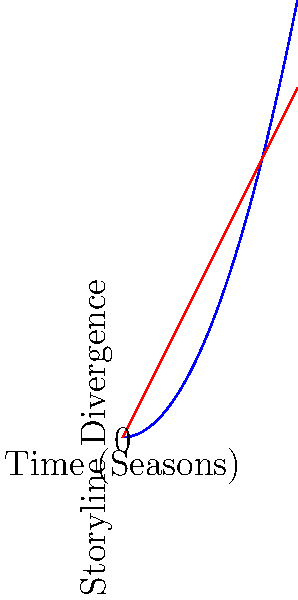In the graph above, two timelines for "How I Met Your Mother" are represented: the original timeline (blue) and an alternate timeline (red). The x-axis represents the progression of seasons, while the y-axis represents the degree of storyline divergence from the original plot. At which season do the two timelines begin to significantly diverge, as indicated by a clear separation between the blue and red lines? To determine when the timelines significantly diverge, we need to analyze the graph step-by-step:

1. The blue curve represents the original timeline, following a quadratic function $f(x) = 0.5x^2$.
2. The red line represents the alternate timeline, following a linear function $g(x) = 2x$.
3. We need to find the point where these two functions start to visibly separate.
4. Mathematically, we could solve this by finding the intersection point of the two functions:
   $0.5x^2 = 2x$
   $0.5x^2 - 2x = 0$
   $x(0.5x - 2) = 0$
   $x = 0$ or $x = 4$
5. However, visually, we can see that the lines start to noticeably diverge just after the point $(1,2)$ on the graph.
6. This point corresponds to the end of Season 1 or the beginning of Season 2.

Therefore, the timelines begin to significantly diverge at the start of Season 2.
Answer: Season 2 